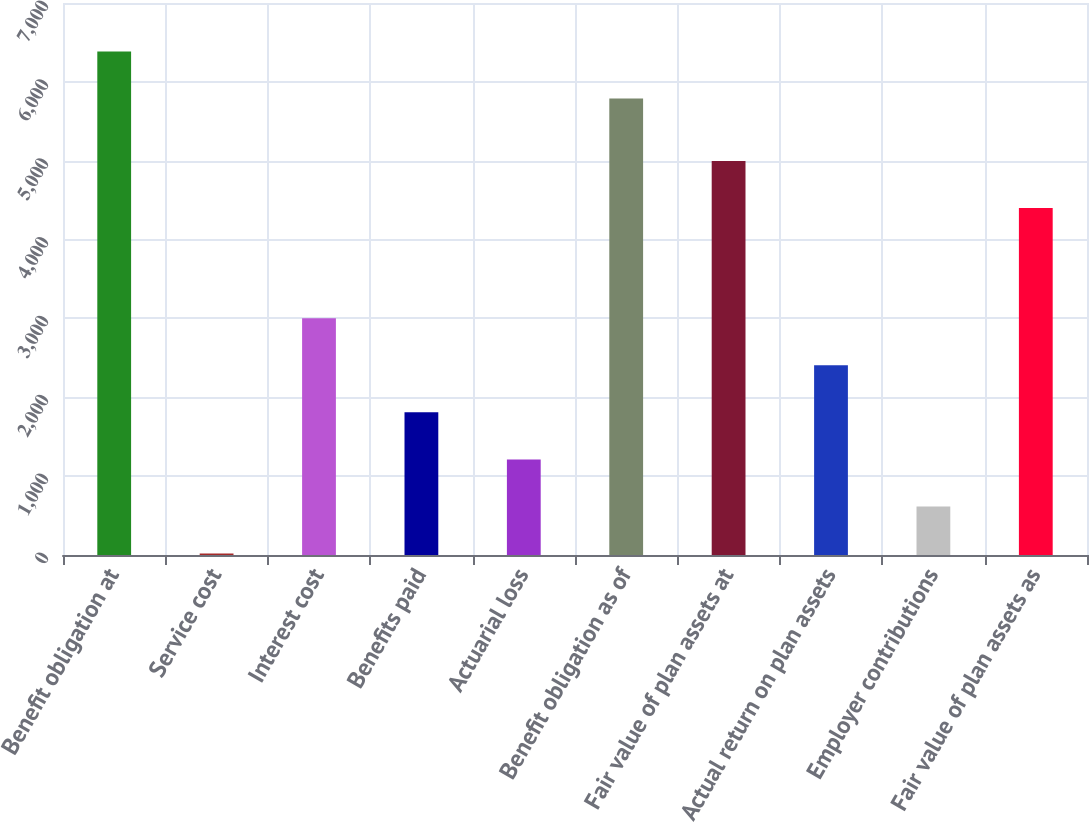<chart> <loc_0><loc_0><loc_500><loc_500><bar_chart><fcel>Benefit obligation at<fcel>Service cost<fcel>Interest cost<fcel>Benefits paid<fcel>Actuarial loss<fcel>Benefit obligation as of<fcel>Fair value of plan assets at<fcel>Actual return on plan assets<fcel>Employer contributions<fcel>Fair value of plan assets as<nl><fcel>6385.7<fcel>19<fcel>3002.5<fcel>1809.1<fcel>1212.4<fcel>5789<fcel>4996.7<fcel>2405.8<fcel>615.7<fcel>4400<nl></chart> 